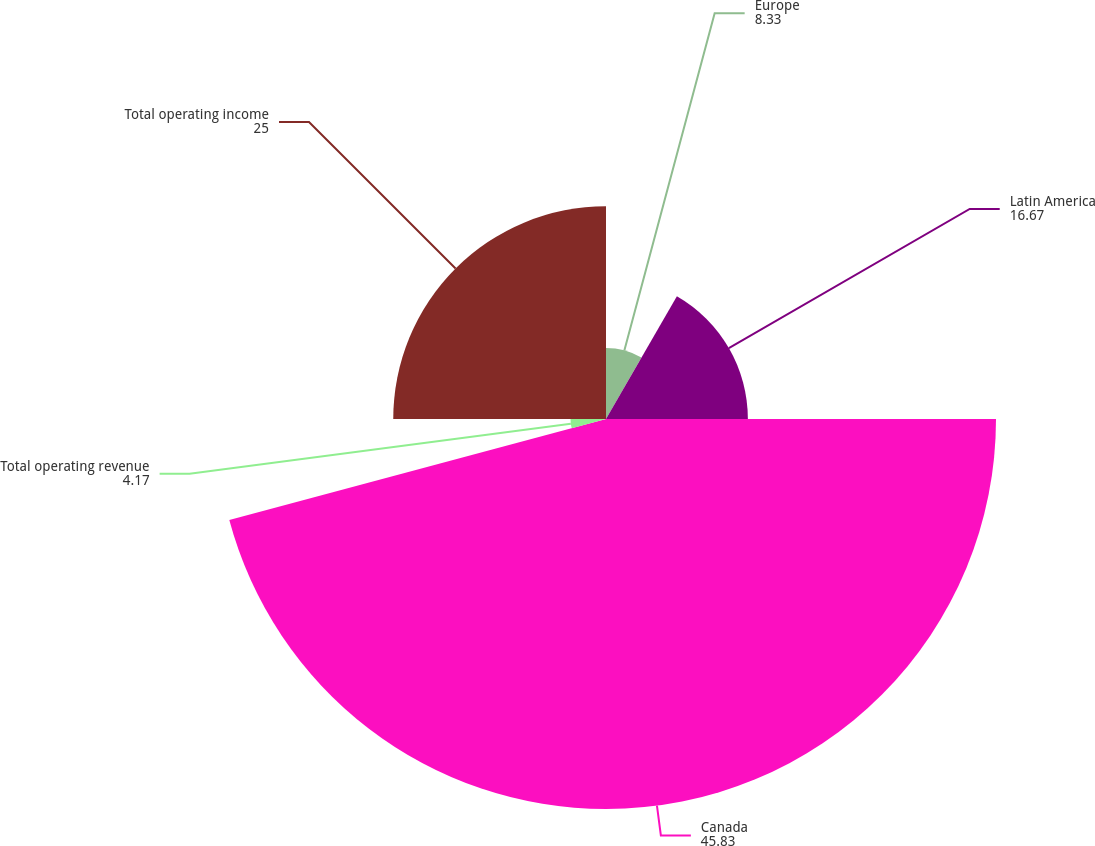<chart> <loc_0><loc_0><loc_500><loc_500><pie_chart><fcel>Europe<fcel>Latin America<fcel>Canada<fcel>Total operating revenue<fcel>Total operating income<nl><fcel>8.33%<fcel>16.67%<fcel>45.83%<fcel>4.17%<fcel>25.0%<nl></chart> 